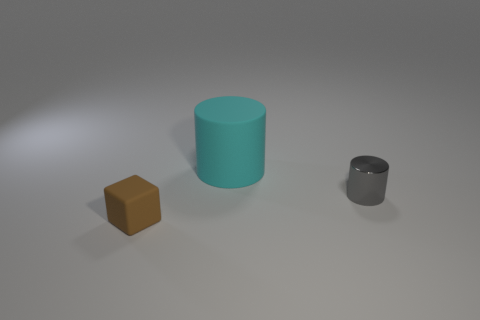Add 3 cyan cylinders. How many objects exist? 6 Subtract all blocks. How many objects are left? 2 Add 3 yellow objects. How many yellow objects exist? 3 Subtract 0 blue spheres. How many objects are left? 3 Subtract all rubber things. Subtract all large yellow cylinders. How many objects are left? 1 Add 3 cubes. How many cubes are left? 4 